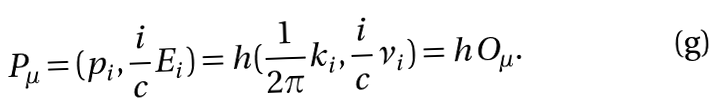Convert formula to latex. <formula><loc_0><loc_0><loc_500><loc_500>P _ { \mu } = ( p _ { i } , \frac { i } { c } E _ { i } ) = h ( \frac { 1 } { 2 \pi } k _ { i } , \frac { i } { c } \nu _ { i } ) = h O _ { \mu } .</formula> 